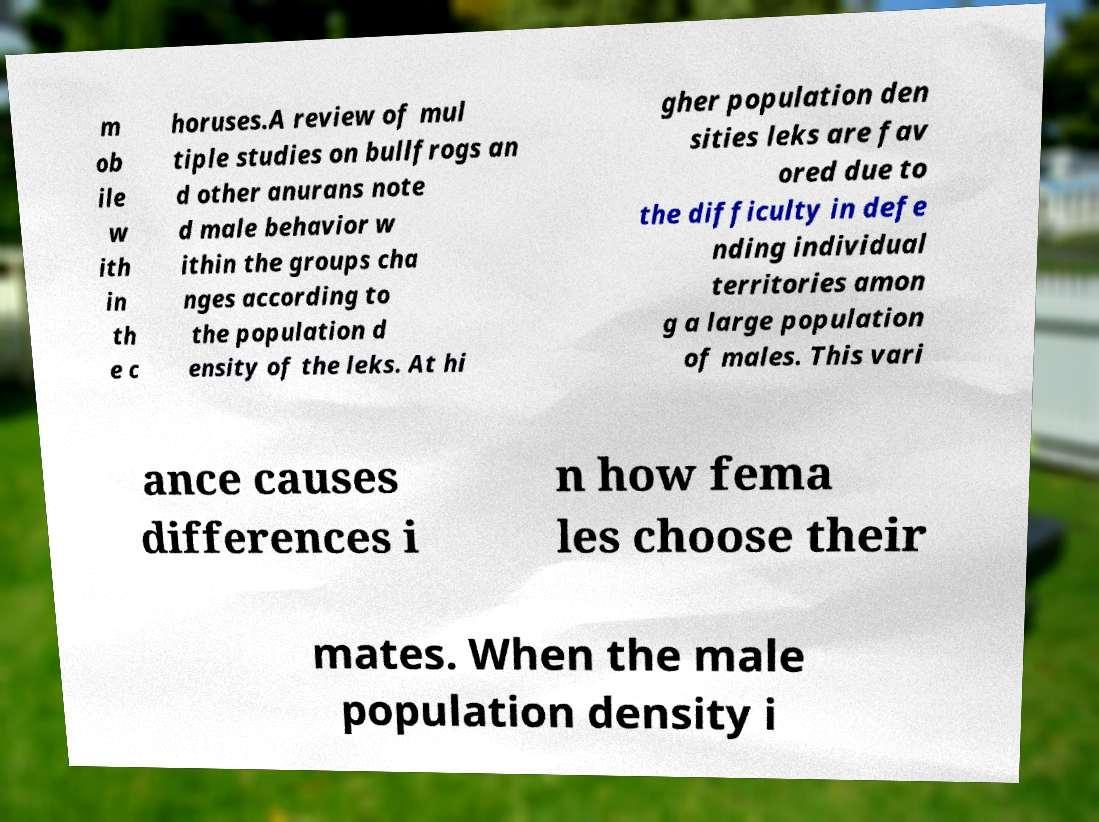Could you assist in decoding the text presented in this image and type it out clearly? m ob ile w ith in th e c horuses.A review of mul tiple studies on bullfrogs an d other anurans note d male behavior w ithin the groups cha nges according to the population d ensity of the leks. At hi gher population den sities leks are fav ored due to the difficulty in defe nding individual territories amon g a large population of males. This vari ance causes differences i n how fema les choose their mates. When the male population density i 